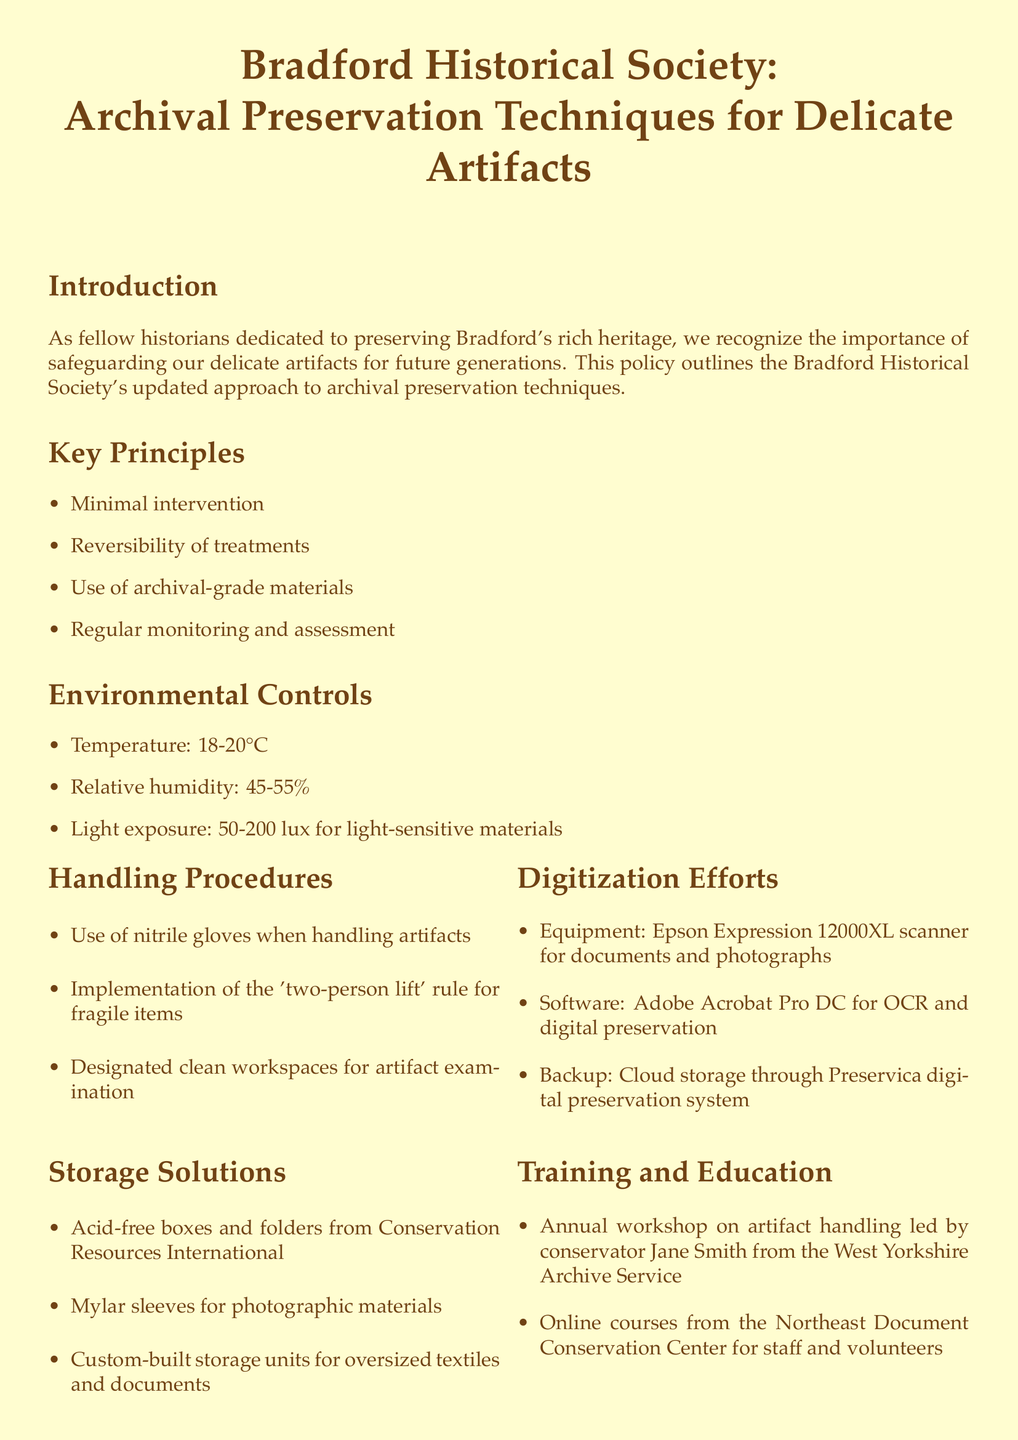What are the key principles of preservation? The key principles include minimal intervention, reversibility of treatments, use of archival-grade materials, and regular monitoring and assessment.
Answer: minimal intervention, reversibility of treatments, use of archival-grade materials, regular monitoring and assessment What is the recommended temperature for environmental controls? The document states a recommended temperature range for environmental controls is between 18-20°C.
Answer: 18-20°C Who leads the annual workshop on artifact handling? The document mentions that the annual workshop on artifact handling is led by conservator Jane Smith from the West Yorkshire Archive Service.
Answer: Jane Smith What equipment is used for digitization efforts? The document lists the Epson Expression 12000XL scanner as the equipment used for digitization efforts.
Answer: Epson Expression 12000XL scanner What is the relative humidity range specified? The specified relative humidity range for environmental controls is 45-55%.
Answer: 45-55% What is the purpose of the 'two-person lift' rule? The 'two-person lift' rule is implemented for handling fragile items to ensure they are lifted safely.
Answer: Fragile items What type of storage solutions are mentioned for photographic materials? The document specifies Mylar sleeves as a storage solution for photographic materials.
Answer: Mylar sleeves What is the annual process for preservation policies and procedures? The document states that there is an annual review of preservation policies and procedures by the Bradford Historical Society's Board of Trustees.
Answer: Annual review What partnership exists for advanced preservation techniques? The document mentions a partnership with the University of Bradford's Department of Archaeological and Forensic Sciences.
Answer: University of Bradford's Department of Archaeological and Forensic Sciences 